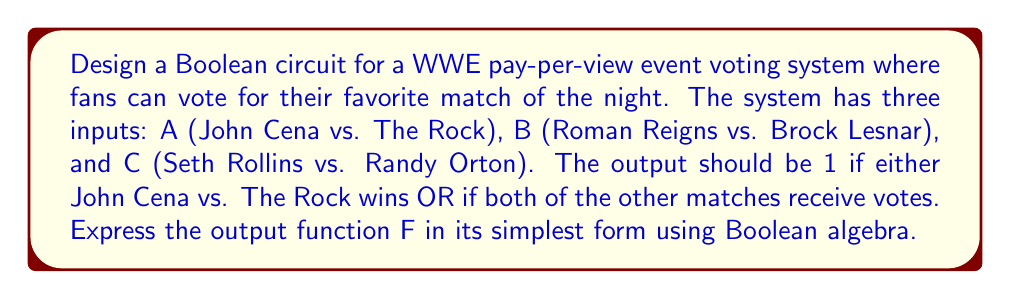Help me with this question. Let's approach this step-by-step:

1) First, let's define our Boolean function F based on the given conditions:
   F = A + (B • C)

   Where:
   A = 1 if John Cena vs. The Rock receives a vote
   B = 1 if Roman Reigns vs. Brock Lesnar receives a vote
   C = 1 if Seth Rollins vs. Randy Orton receives a vote

2) This function is already in its simplest form, as it uses only basic operations (OR and AND) and cannot be further reduced.

3) To verify, we can create a truth table:

   A | B | C | F
   0 | 0 | 0 | 0
   0 | 0 | 1 | 0
   0 | 1 | 0 | 0
   0 | 1 | 1 | 1
   1 | 0 | 0 | 1
   1 | 0 | 1 | 1
   1 | 1 | 0 | 1
   1 | 1 | 1 | 1

4) The truth table confirms that F = 1 when A = 1 (John Cena vs. The Rock wins) OR when both B and C are 1 (both other matches receive votes).

5) The Boolean circuit for this function would consist of an AND gate for (B • C) and an OR gate to combine this with A.

[asy]
unitsize(1cm);

pair A = (0,3), B = (0,2), C = (0,1);
pair AND = (2,1.5), OR = (4,2);

draw(A--OR);
draw(B--AND);
draw(C--AND);
draw(AND--OR);

label("A", A, W);
label("B", B, W);
label("C", C, W);
label("F", (5,2), E);

draw(circle(AND,0.5));
draw(circle(OR,0.5));

label("&", AND);
label("≥1", OR);
[/asy]
Answer: $$F = A + (B • C)$$ 